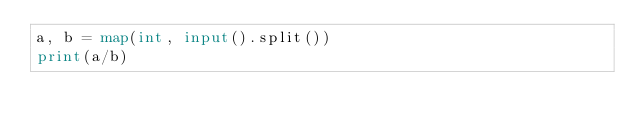<code> <loc_0><loc_0><loc_500><loc_500><_Python_>a, b = map(int, input().split())
print(a/b)</code> 